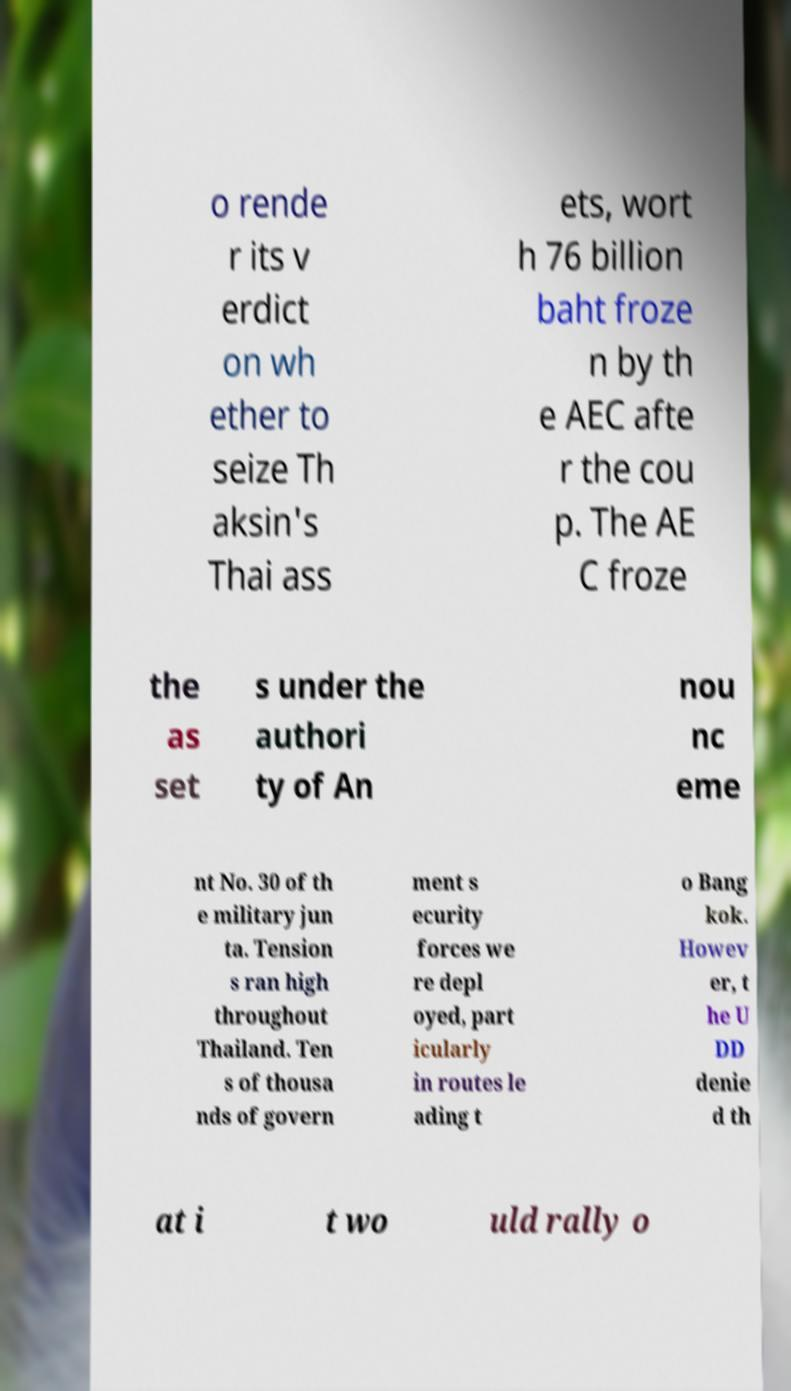Could you extract and type out the text from this image? o rende r its v erdict on wh ether to seize Th aksin's Thai ass ets, wort h 76 billion baht froze n by th e AEC afte r the cou p. The AE C froze the as set s under the authori ty of An nou nc eme nt No. 30 of th e military jun ta. Tension s ran high throughout Thailand. Ten s of thousa nds of govern ment s ecurity forces we re depl oyed, part icularly in routes le ading t o Bang kok. Howev er, t he U DD denie d th at i t wo uld rally o 